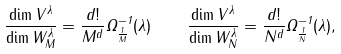Convert formula to latex. <formula><loc_0><loc_0><loc_500><loc_500>\frac { \dim V ^ { \lambda } } { \dim W _ { M } ^ { \lambda } } = \frac { d ! } { M ^ { d } } \Omega _ { \frac { 1 } { M } } ^ { - 1 } ( \lambda ) \quad \frac { \dim V ^ { \lambda } } { \dim W _ { N } ^ { \lambda } } = \frac { d ! } { N ^ { d } } \Omega _ { \frac { 1 } { N } } ^ { - 1 } ( \lambda ) ,</formula> 